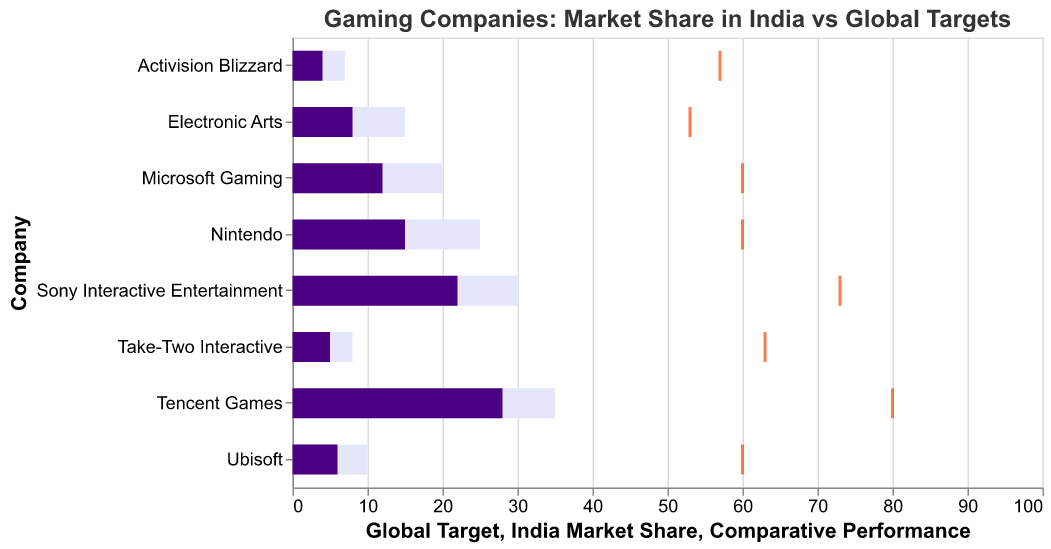How is the comparative performance represented in the chart? The comparative performance is represented by orange ticks positioned along the x-axis. Each tick indicates the comparative performance score out of 100.
Answer: Orange ticks along the x-axis Which company has the highest market share in India? By looking at the dark purple bars, the company with the longest bar for India Market Share is Tencent Games at 28%.
Answer: Tencent Games What is the global target market share for Sony Interactive Entertainment? By observing the light purple bars, Sony Interactive Entertainment has a global target market share of 30%.
Answer: 30% How does Microsoft Gaming's India market share compare to its global target market share? Microsoft Gaming's India market share is 12%, while its global target market share is 20%. The India market share is therefore 8% lower than the global target.
Answer: 8% lower What is the difference between the global target and India market share for Electronic Arts? Electronic Arts has a global target of 15% and an India market share of 8%. The difference is 15% - 8% = 7%.
Answer: 7% Which company has the lowest comparative performance? By examining the orange ticks, the company with the lowest comparative performance score is Electronic Arts with a score of 53.
Answer: Electronic Arts Among Tencent Games, Sony Interactive Entertainment, and Nintendo, which company is closest to its global target? By comparing the comparative performance ticks, Tencent Games has a score of 80, Sony Interactive Entertainment has 73, and Nintendo has 60. Tencent Games is closest to its global target.
Answer: Tencent Games How many companies have an India market share greater than 10%? By checking the dark purple bars, Tencent Games (28%), Sony Interactive Entertainment (22%), and Nintendo (15%), and Microsoft Gaming (12%) have an India market share greater than 10%.
Answer: 4 companies Compare the India market share and global target of Ubisoft. Ubisoft has an India market share of 6% and a global target of 10%, meaning it has achieved 60% of its global target.
Answer: 6% India market share, 10% global target What is the range of the comparative performance scores among all companies? The lowest comparative performance score is 53 (Electronic Arts) and the highest is 80 (Tencent Games), leading to a range of 80 - 53 = 27.
Answer: 27 